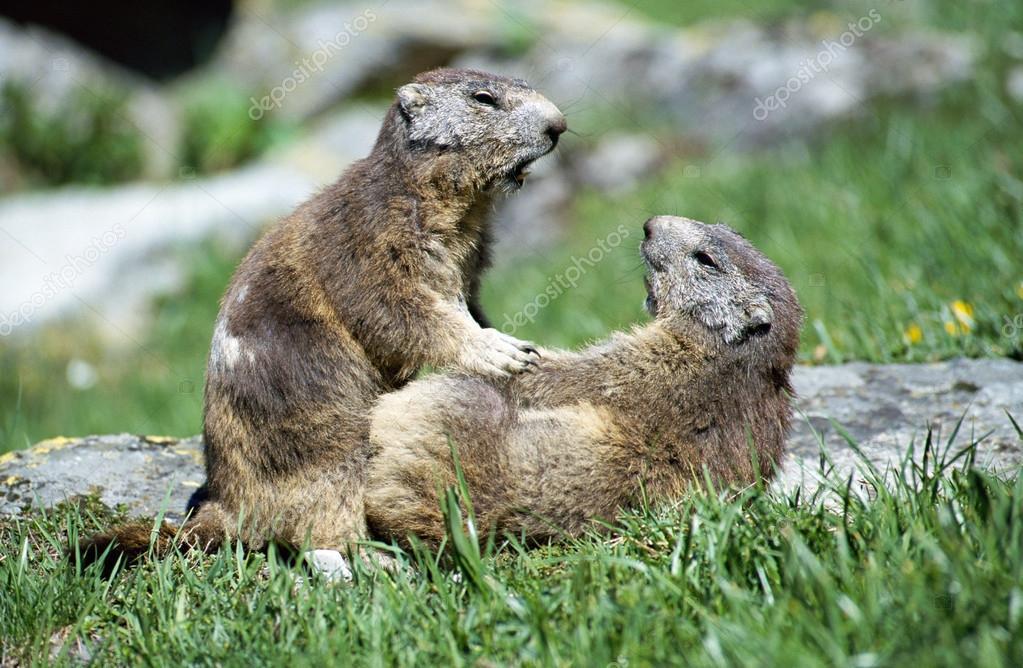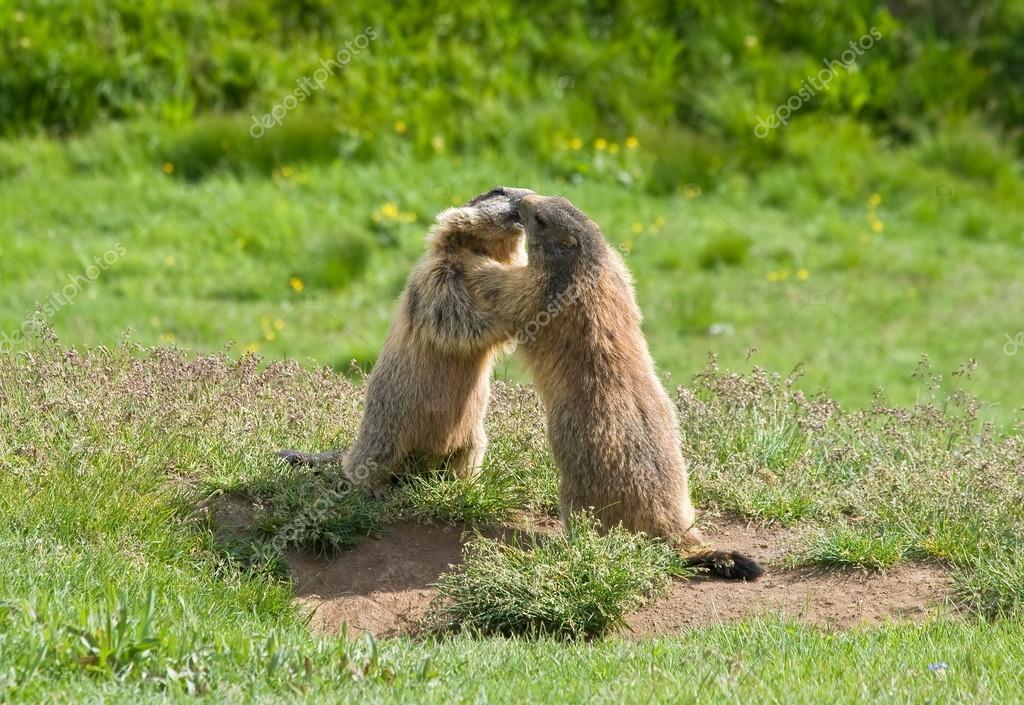The first image is the image on the left, the second image is the image on the right. For the images displayed, is the sentence "Right image shows two marmots on all fours posed face-to-face." factually correct? Answer yes or no. No. The first image is the image on the left, the second image is the image on the right. Evaluate the accuracy of this statement regarding the images: "Two animals are interacting in a field in both images.". Is it true? Answer yes or no. Yes. 